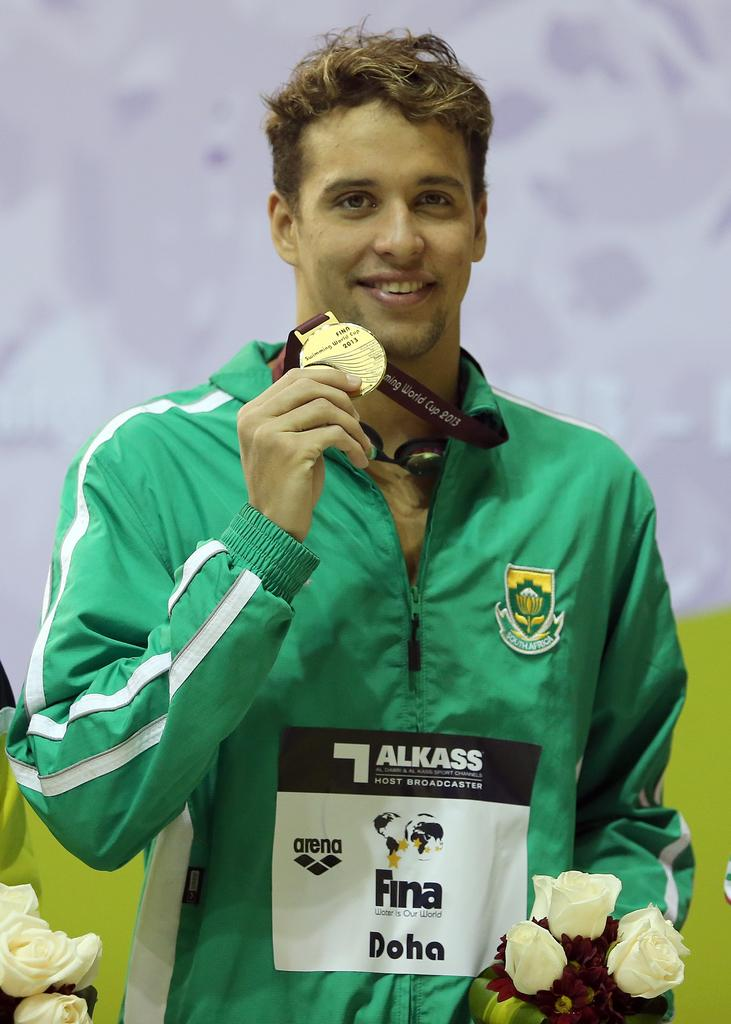What is the main subject of the image? There is a man in the image. What is the man doing in the image? The man is standing and smiling. What objects is the man holding in the image? The man is holding a medal and flowers. Are there any additional flowers visible in the image? Yes, there are flowers at the left bottom of the image. How would you describe the background of the image? The background of the image is blurry. Can you see any ghosts in the image? No, there are no ghosts present in the image. Is the man in the image sinking into quicksand? No, the man is standing on a solid surface, and there is no quicksand in the image. 